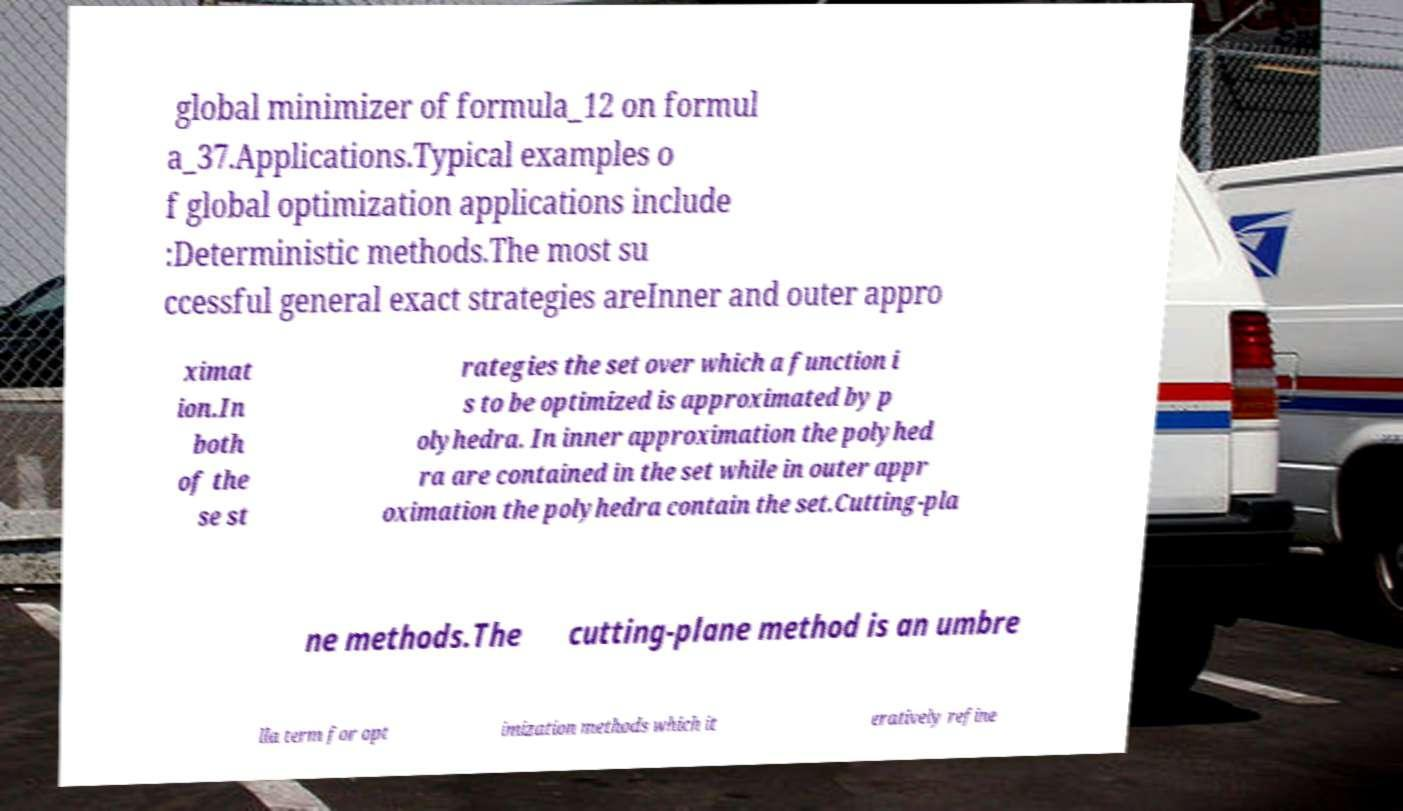I need the written content from this picture converted into text. Can you do that? global minimizer of formula_12 on formul a_37.Applications.Typical examples o f global optimization applications include :Deterministic methods.The most su ccessful general exact strategies areInner and outer appro ximat ion.In both of the se st rategies the set over which a function i s to be optimized is approximated by p olyhedra. In inner approximation the polyhed ra are contained in the set while in outer appr oximation the polyhedra contain the set.Cutting-pla ne methods.The cutting-plane method is an umbre lla term for opt imization methods which it eratively refine 